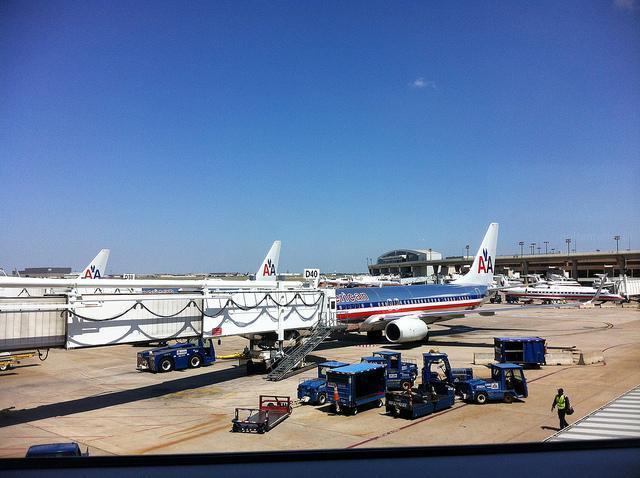How many trucks are in the photo?
Give a very brief answer. 4. How many bird heads are in the scene?
Give a very brief answer. 0. 